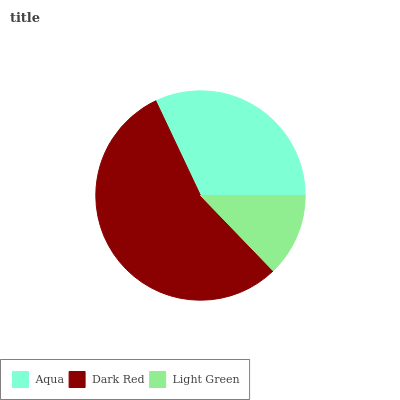Is Light Green the minimum?
Answer yes or no. Yes. Is Dark Red the maximum?
Answer yes or no. Yes. Is Dark Red the minimum?
Answer yes or no. No. Is Light Green the maximum?
Answer yes or no. No. Is Dark Red greater than Light Green?
Answer yes or no. Yes. Is Light Green less than Dark Red?
Answer yes or no. Yes. Is Light Green greater than Dark Red?
Answer yes or no. No. Is Dark Red less than Light Green?
Answer yes or no. No. Is Aqua the high median?
Answer yes or no. Yes. Is Aqua the low median?
Answer yes or no. Yes. Is Light Green the high median?
Answer yes or no. No. Is Dark Red the low median?
Answer yes or no. No. 